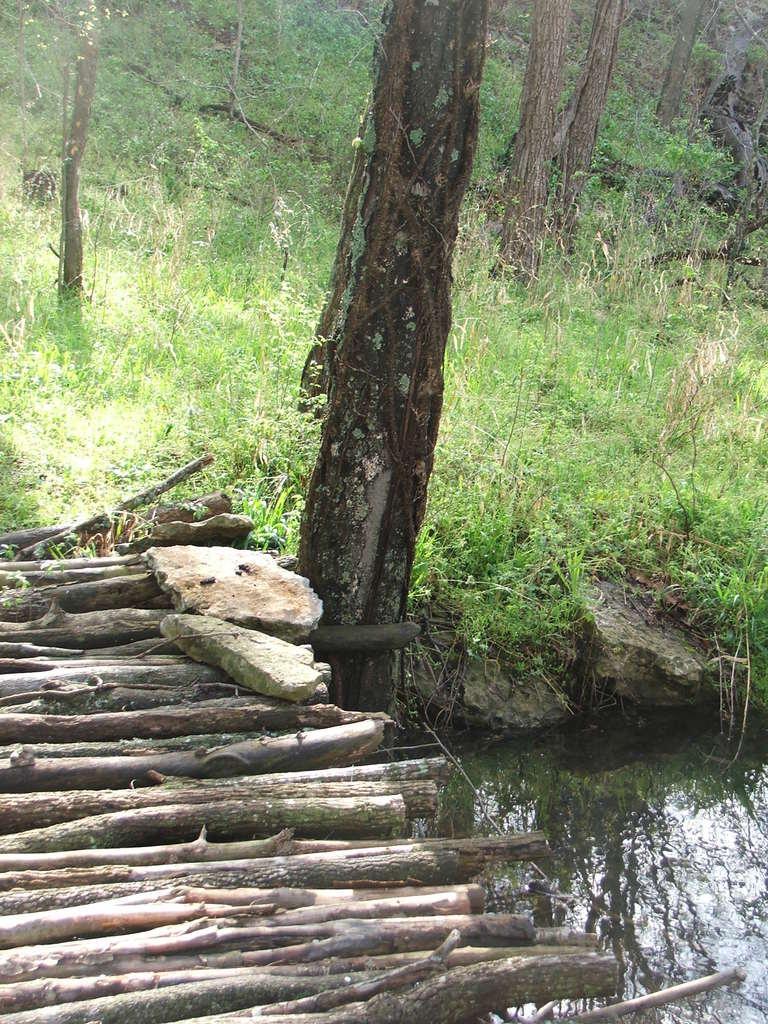Please provide a concise description of this image. In this image I can see a wood bridge, stones. In the background I can see grass, trees and water. This image is taken may be in the forest. 